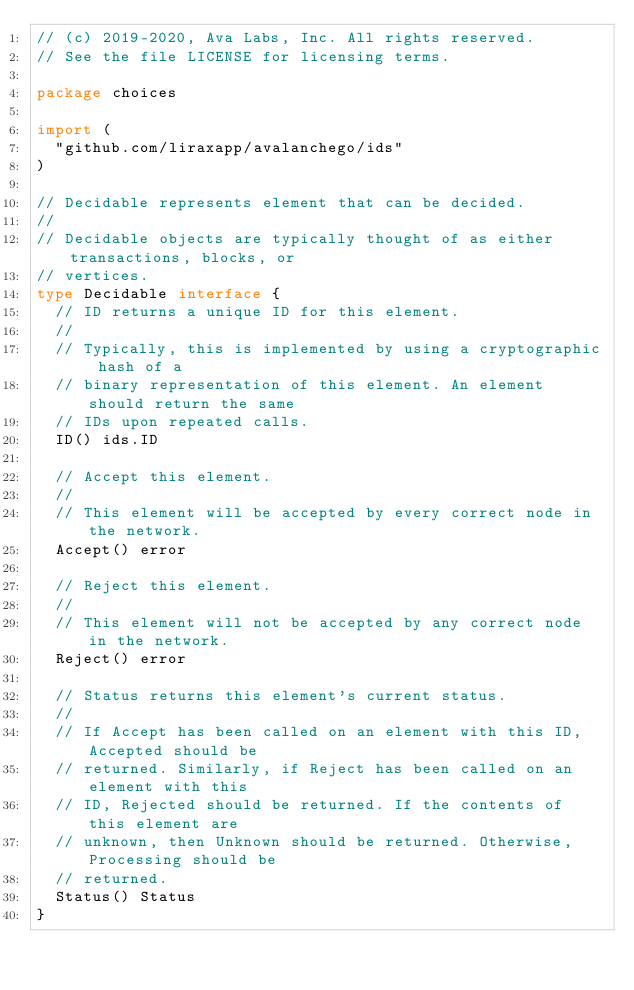Convert code to text. <code><loc_0><loc_0><loc_500><loc_500><_Go_>// (c) 2019-2020, Ava Labs, Inc. All rights reserved.
// See the file LICENSE for licensing terms.

package choices

import (
	"github.com/liraxapp/avalanchego/ids"
)

// Decidable represents element that can be decided.
//
// Decidable objects are typically thought of as either transactions, blocks, or
// vertices.
type Decidable interface {
	// ID returns a unique ID for this element.
	//
	// Typically, this is implemented by using a cryptographic hash of a
	// binary representation of this element. An element should return the same
	// IDs upon repeated calls.
	ID() ids.ID

	// Accept this element.
	//
	// This element will be accepted by every correct node in the network.
	Accept() error

	// Reject this element.
	//
	// This element will not be accepted by any correct node in the network.
	Reject() error

	// Status returns this element's current status.
	//
	// If Accept has been called on an element with this ID, Accepted should be
	// returned. Similarly, if Reject has been called on an element with this
	// ID, Rejected should be returned. If the contents of this element are
	// unknown, then Unknown should be returned. Otherwise, Processing should be
	// returned.
	Status() Status
}
</code> 